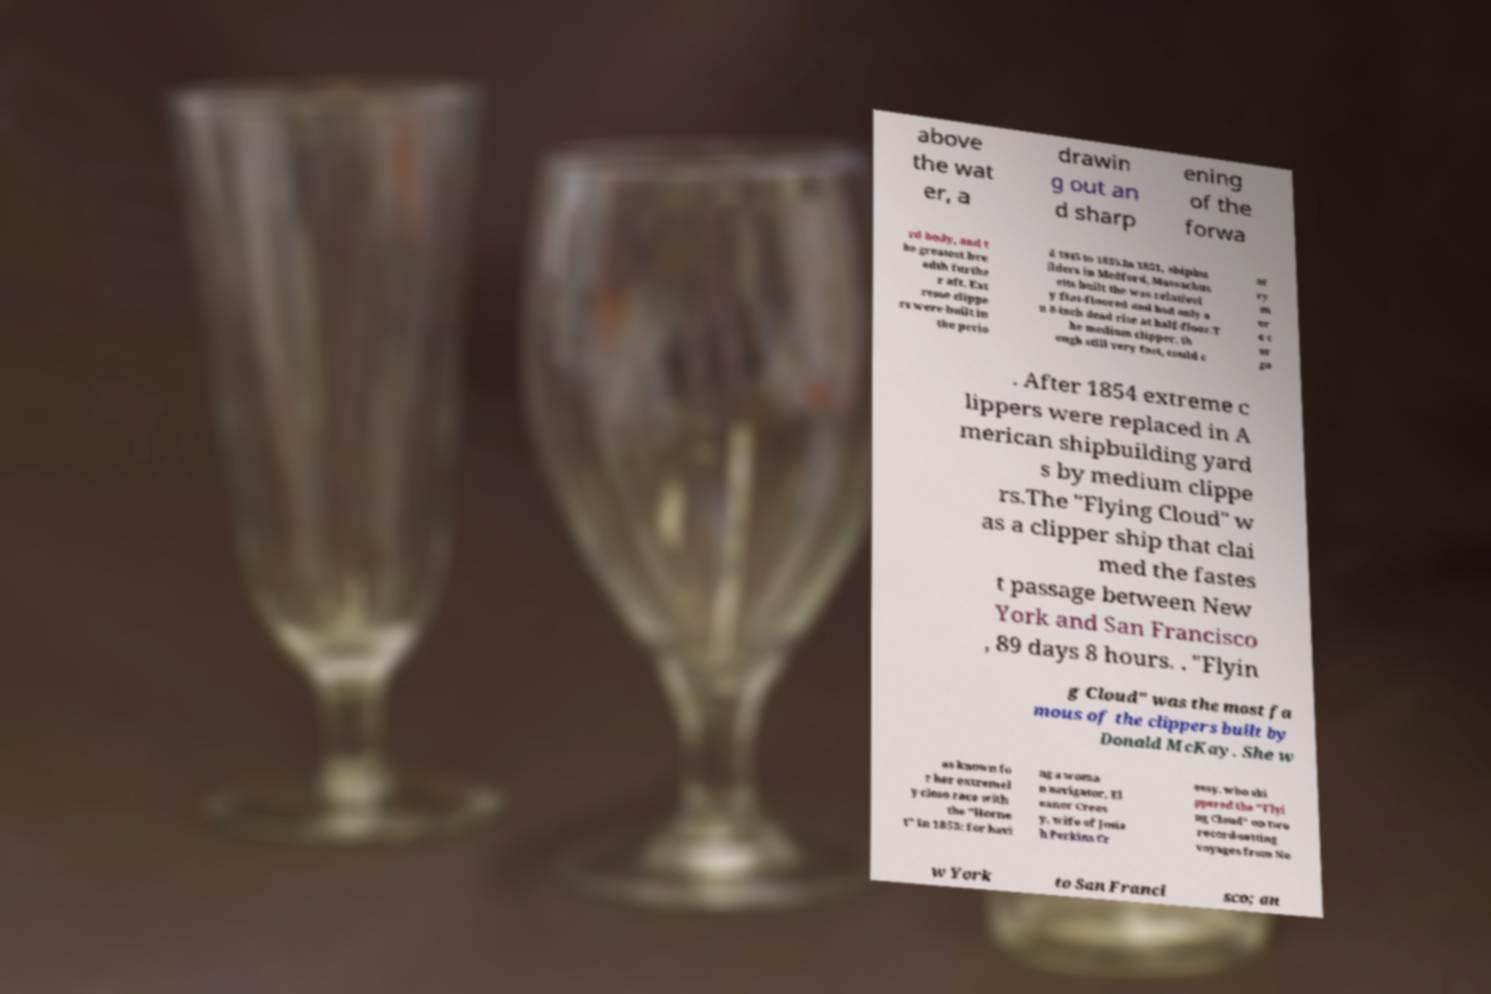I need the written content from this picture converted into text. Can you do that? above the wat er, a drawin g out an d sharp ening of the forwa rd body, and t he greatest bre adth furthe r aft. Ext reme clippe rs were built in the perio d 1845 to 1855.In 1851, shipbu ilders in Medford, Massachus etts built the was relativel y flat-floored and had only a n 8-inch dead rise at half-floor.T he medium clipper, th ough still very fast, could c ar ry m or e c ar go . After 1854 extreme c lippers were replaced in A merican shipbuilding yard s by medium clippe rs.The "Flying Cloud" w as a clipper ship that clai med the fastes t passage between New York and San Francisco , 89 days 8 hours. . "Flyin g Cloud" was the most fa mous of the clippers built by Donald McKay. She w as known fo r her extremel y close race with the "Horne t" in 1853; for havi ng a woma n navigator, El eanor Crees y, wife of Josia h Perkins Cr eesy, who ski ppered the "Flyi ng Cloud" on two record-setting voyages from Ne w York to San Franci sco; an 